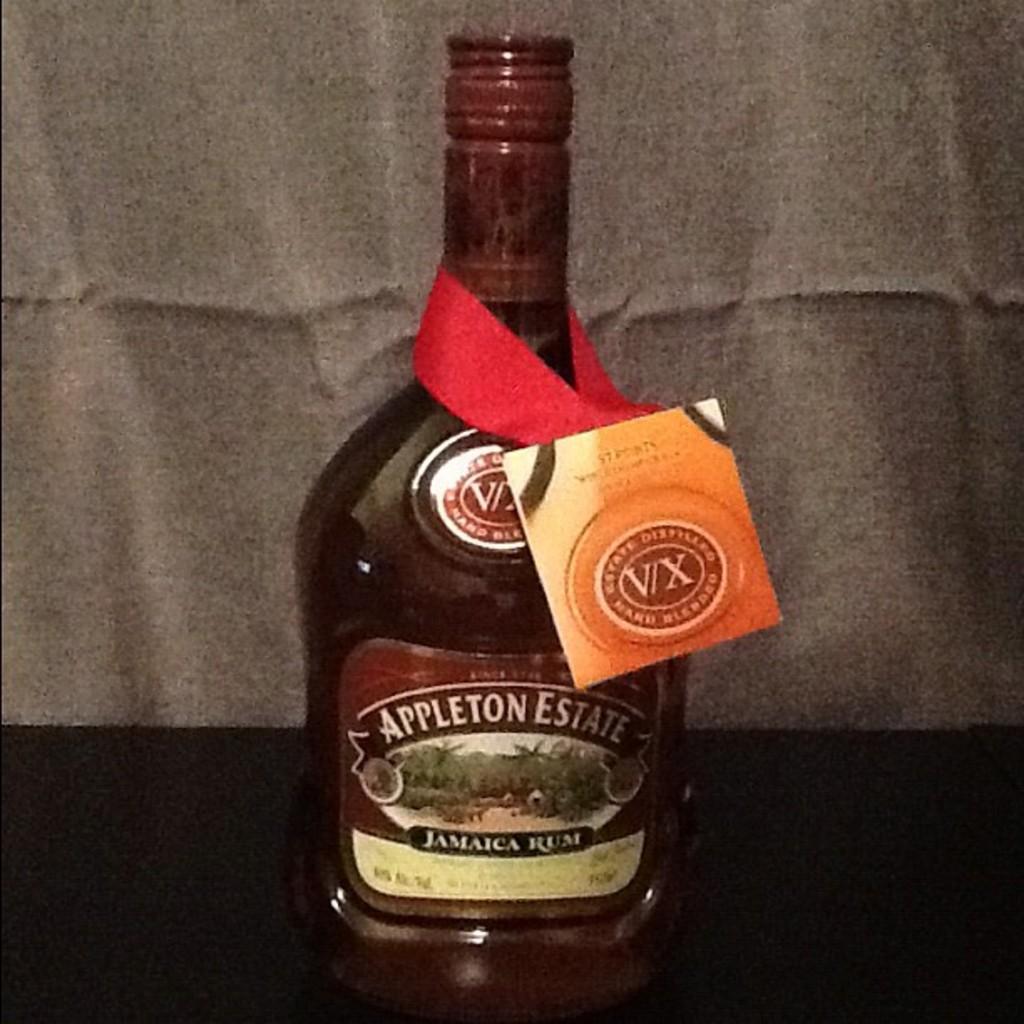What kind of alcohol is in the bottle?
Keep it short and to the point. Jamaica rum. What brand is the alcohol?
Your answer should be compact. Appleton estate. 